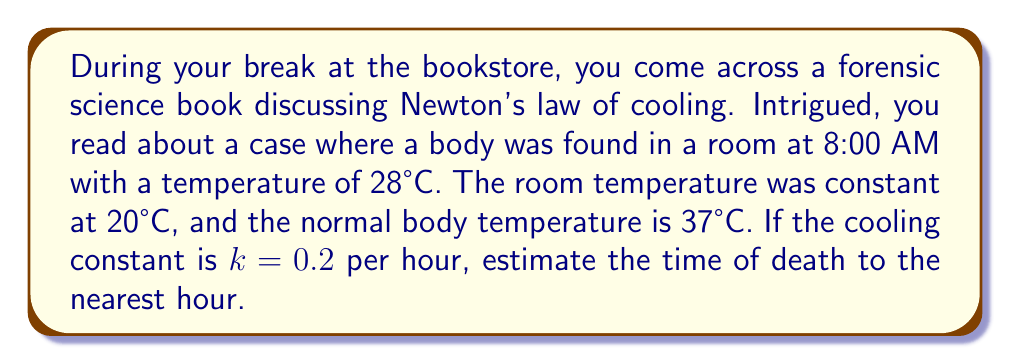Can you answer this question? To solve this problem, we'll use Newton's law of cooling and the given information:

1) Newton's law of cooling is given by:
   $$T(t) = T_s + (T_0 - T_s)e^{-kt}$$
   Where:
   $T(t)$ = Temperature at time $t$
   $T_s$ = Surrounding temperature
   $T_0$ = Initial temperature
   $k$ = Cooling constant
   $t$ = Time elapsed

2) We know:
   $T(t) = 28°C$ (body temperature when found)
   $T_s = 20°C$ (room temperature)
   $T_0 = 37°C$ (normal body temperature)
   $k = 0.2$ per hour

3) Substituting these values into the equation:
   $$28 = 20 + (37 - 20)e^{-0.2t}$$

4) Simplify:
   $$8 = 17e^{-0.2t}$$

5) Divide both sides by 17:
   $$\frac{8}{17} = e^{-0.2t}$$

6) Take the natural log of both sides:
   $$\ln(\frac{8}{17}) = -0.2t$$

7) Solve for $t$:
   $$t = -\frac{\ln(\frac{8}{17})}{0.2} \approx 7.58 \text{ hours}$$

8) Since the body was found at 8:00 AM, we subtract 7.58 hours:
   8:00 AM - 7.58 hours ≈ 12:25 AM (rounded to the nearest hour: 12:00 AM or midnight)
Answer: 12:00 AM (midnight) 